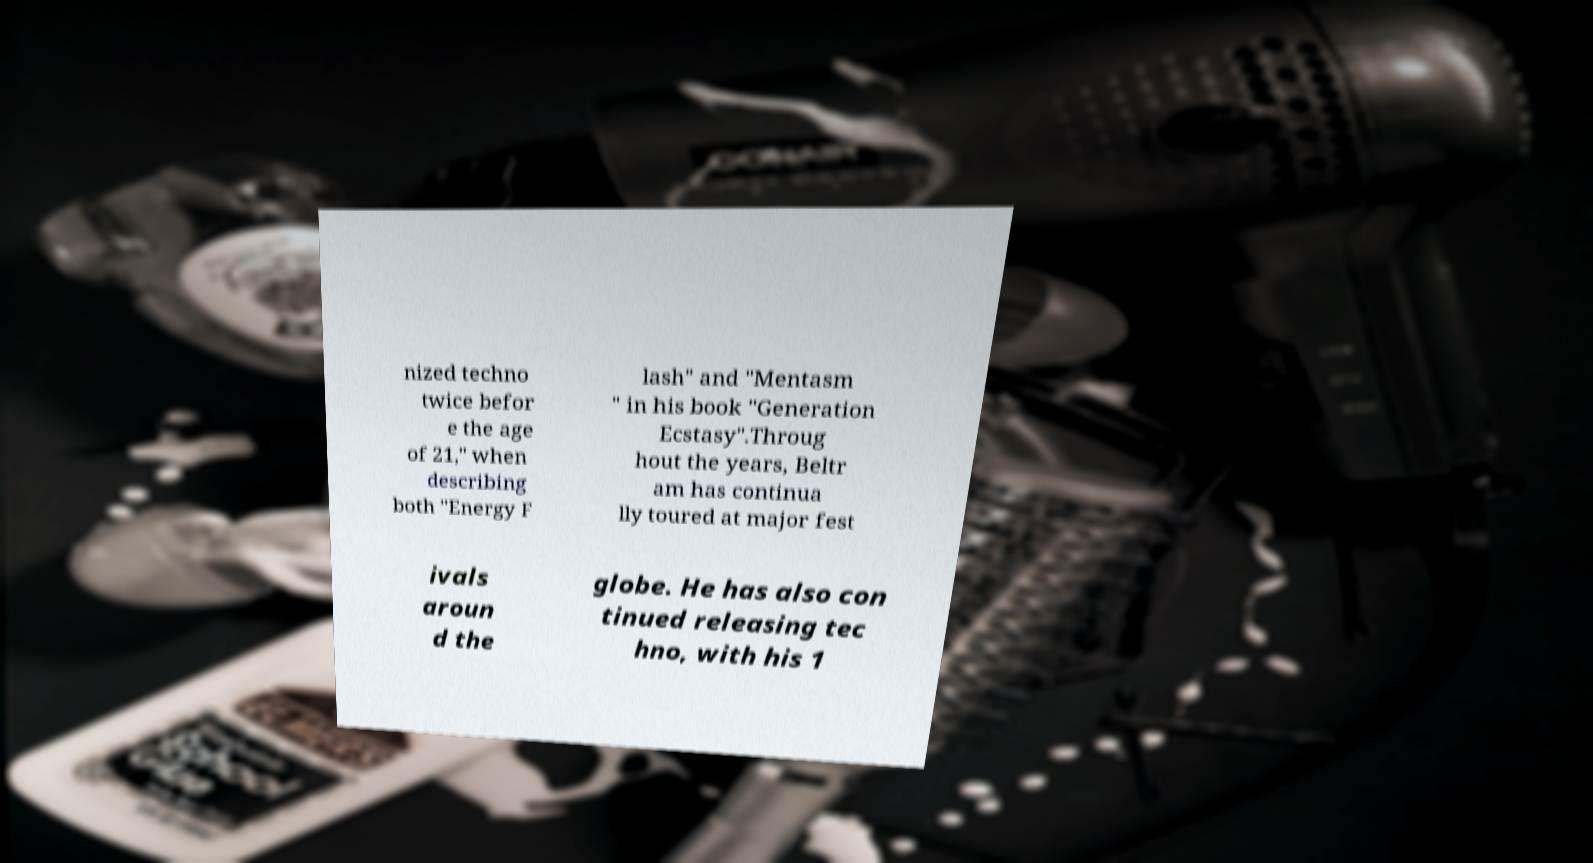Could you extract and type out the text from this image? nized techno twice befor e the age of 21," when describing both "Energy F lash" and "Mentasm " in his book "Generation Ecstasy".Throug hout the years, Beltr am has continua lly toured at major fest ivals aroun d the globe. He has also con tinued releasing tec hno, with his 1 